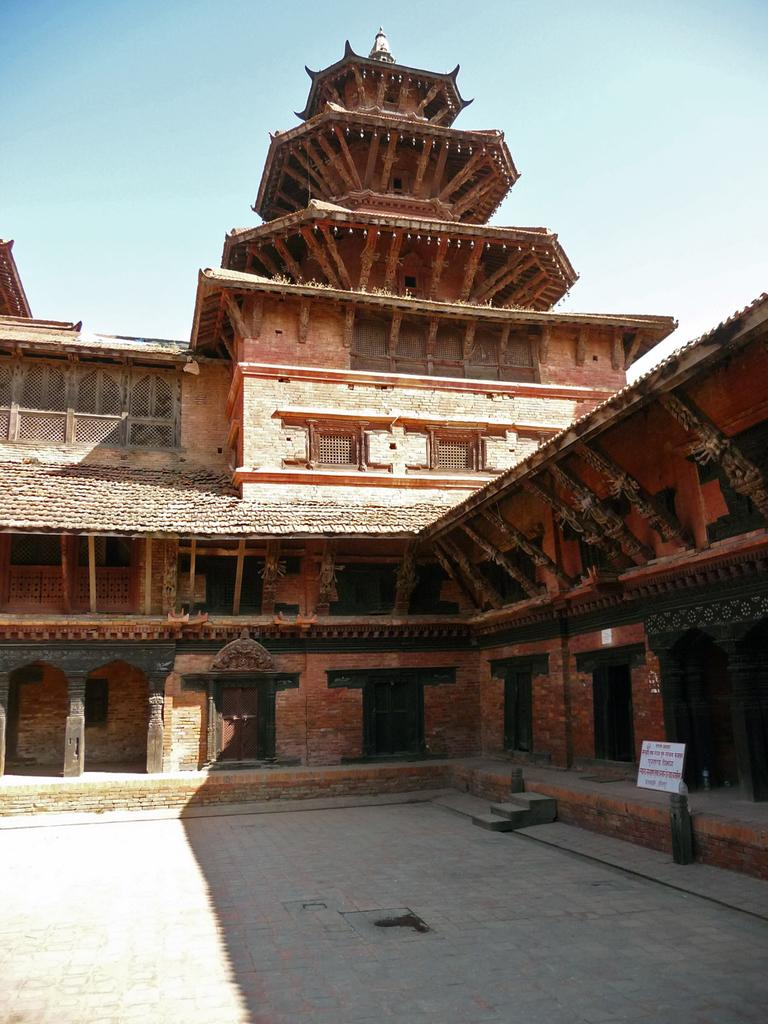What is the main structure in the center of the image? There is a building in the center of the image. What architectural features can be seen in the image? There are pillars in the image. What is located near the bottom of the image? There is a walkway at the bottom of the image. What is visible at the top of the image? The sky is visible at the top of the image. What object is present in the image that might contain information or announcements? There is a board in the image. How many pizzas are being carried by the monkey in the image? There is no monkey or pizzas present in the image. What is the back of the building like in the image? The provided facts do not mention the back of the building, so we cannot answer this question. 